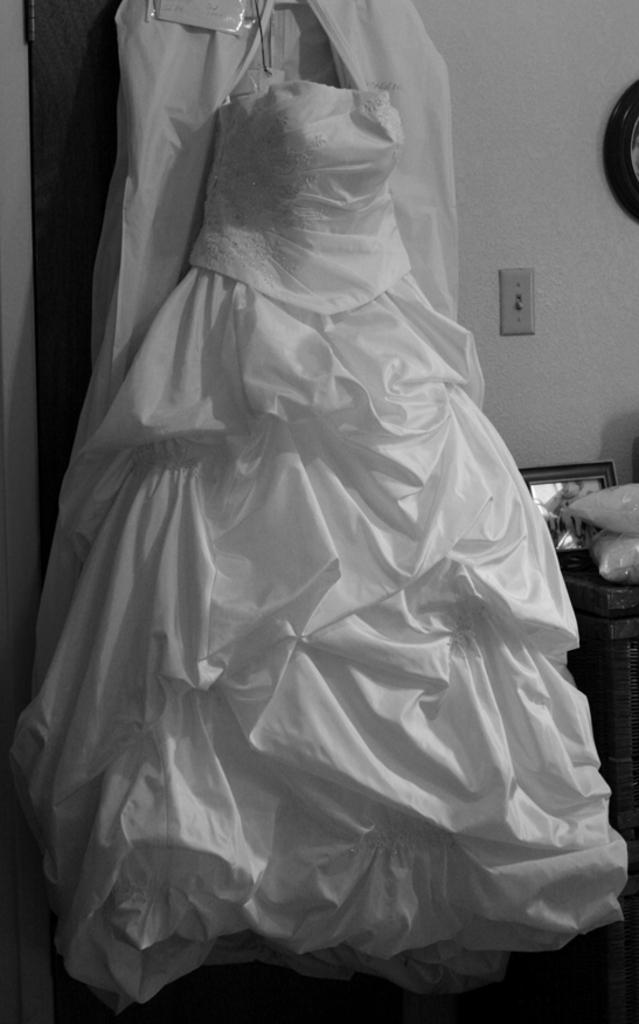What is the main object in the image? There is a white color sheet in the image. What can be seen in the background of the image? There is a wall, a mirror, and a switch socket in the background of the image. What type of noise can be heard coming from the fireman in the image? There is no fireman present in the image, so it's not possible to determine what, if any, noise might be heard. 